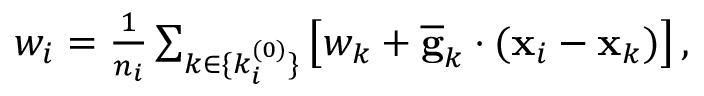<formula> <loc_0><loc_0><loc_500><loc_500>\begin{array} { r } { { w } _ { i } = \frac { 1 } { n _ { i } } \sum _ { k \in \{ k _ { i } ^ { ( 0 ) } \} } \left [ { w } _ { k } + \overline { g } _ { k } \cdot ( { x } _ { i } - { x } _ { k } ) \right ] , } \end{array}</formula> 